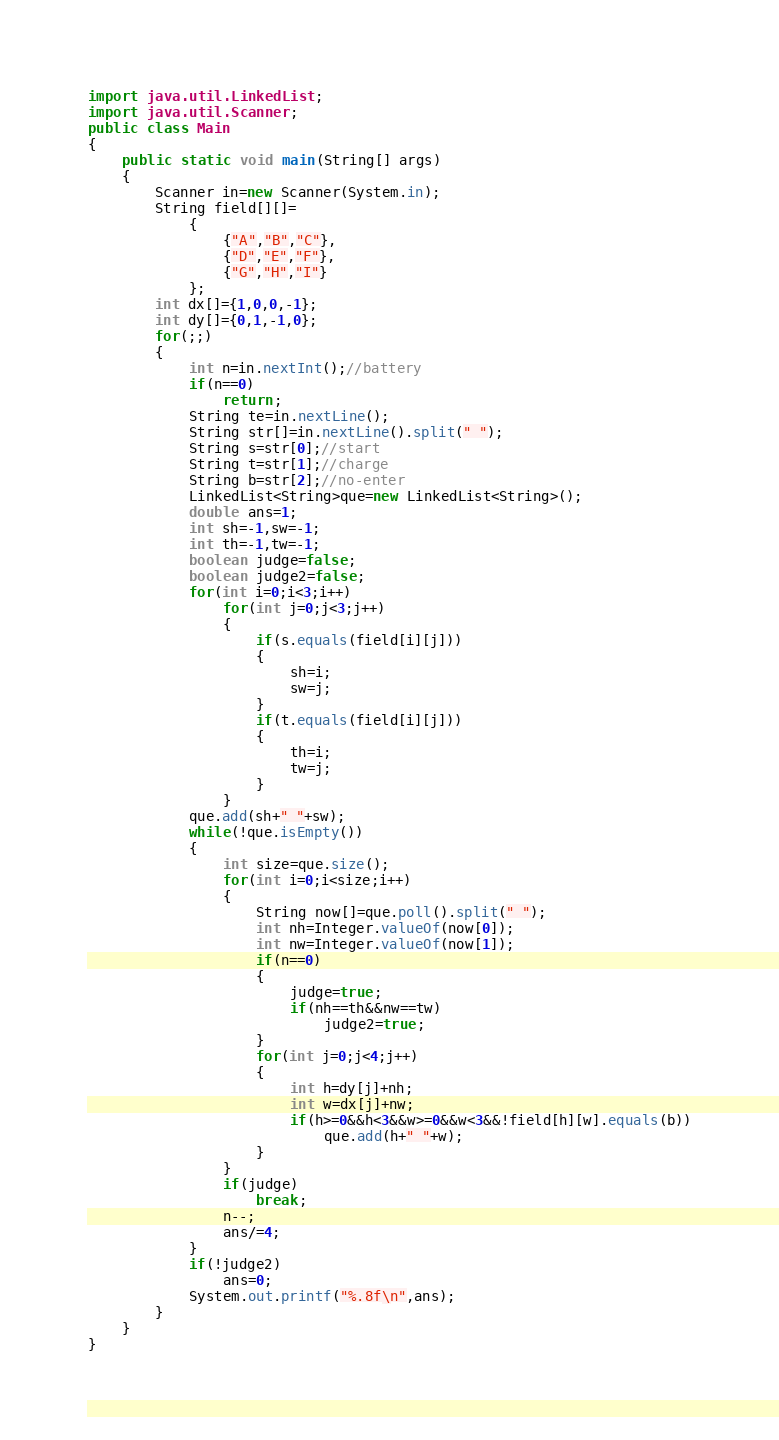<code> <loc_0><loc_0><loc_500><loc_500><_Java_>import java.util.LinkedList;
import java.util.Scanner;
public class Main
{
	public static void main(String[] args) 
	{
		Scanner in=new Scanner(System.in);
		String field[][]=
			{
				{"A","B","C"},
				{"D","E","F"},
				{"G","H","I"}	
			};
		int dx[]={1,0,0,-1};
		int dy[]={0,1,-1,0};
		for(;;)
		{
			int n=in.nextInt();//battery
			if(n==0)
				return;
			String te=in.nextLine();
			String str[]=in.nextLine().split(" ");
			String s=str[0];//start
			String t=str[1];//charge
			String b=str[2];//no-enter
			LinkedList<String>que=new LinkedList<String>();
			double ans=1;
			int sh=-1,sw=-1;
			int th=-1,tw=-1;
			boolean judge=false;
			boolean judge2=false;
			for(int i=0;i<3;i++)
				for(int j=0;j<3;j++)
				{
					if(s.equals(field[i][j]))
					{
						sh=i;
						sw=j;
					}
					if(t.equals(field[i][j]))
					{
						th=i;
						tw=j;
					}
				}
			que.add(sh+" "+sw);
			while(!que.isEmpty())
			{
				int size=que.size();
				for(int i=0;i<size;i++)
				{
					String now[]=que.poll().split(" ");
					int nh=Integer.valueOf(now[0]);
					int nw=Integer.valueOf(now[1]);
					if(n==0)
					{
						judge=true;
						if(nh==th&&nw==tw)
							judge2=true;
					}
					for(int j=0;j<4;j++)
					{
						int h=dy[j]+nh;
						int w=dx[j]+nw;
						if(h>=0&&h<3&&w>=0&&w<3&&!field[h][w].equals(b))
							que.add(h+" "+w);
					}
				}
				if(judge)
					break;
				n--;
				ans/=4;
			}
			if(!judge2)
				ans=0;
			System.out.printf("%.8f\n",ans);
		}
	}
}</code> 